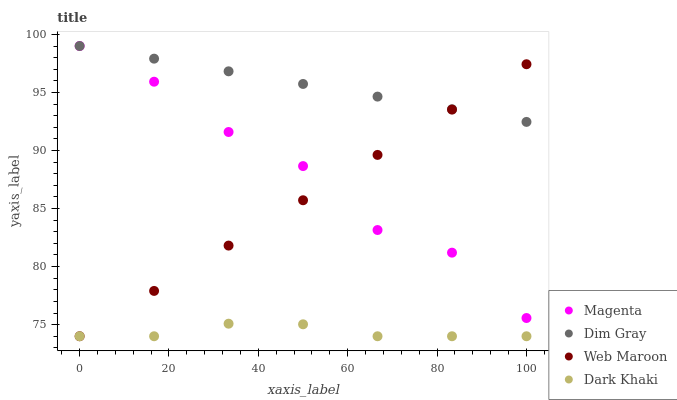Does Dark Khaki have the minimum area under the curve?
Answer yes or no. Yes. Does Dim Gray have the maximum area under the curve?
Answer yes or no. Yes. Does Magenta have the minimum area under the curve?
Answer yes or no. No. Does Magenta have the maximum area under the curve?
Answer yes or no. No. Is Web Maroon the smoothest?
Answer yes or no. Yes. Is Magenta the roughest?
Answer yes or no. Yes. Is Dim Gray the smoothest?
Answer yes or no. No. Is Dim Gray the roughest?
Answer yes or no. No. Does Dark Khaki have the lowest value?
Answer yes or no. Yes. Does Magenta have the lowest value?
Answer yes or no. No. Does Dim Gray have the highest value?
Answer yes or no. Yes. Does Web Maroon have the highest value?
Answer yes or no. No. Is Dark Khaki less than Magenta?
Answer yes or no. Yes. Is Magenta greater than Dark Khaki?
Answer yes or no. Yes. Does Web Maroon intersect Dim Gray?
Answer yes or no. Yes. Is Web Maroon less than Dim Gray?
Answer yes or no. No. Is Web Maroon greater than Dim Gray?
Answer yes or no. No. Does Dark Khaki intersect Magenta?
Answer yes or no. No. 